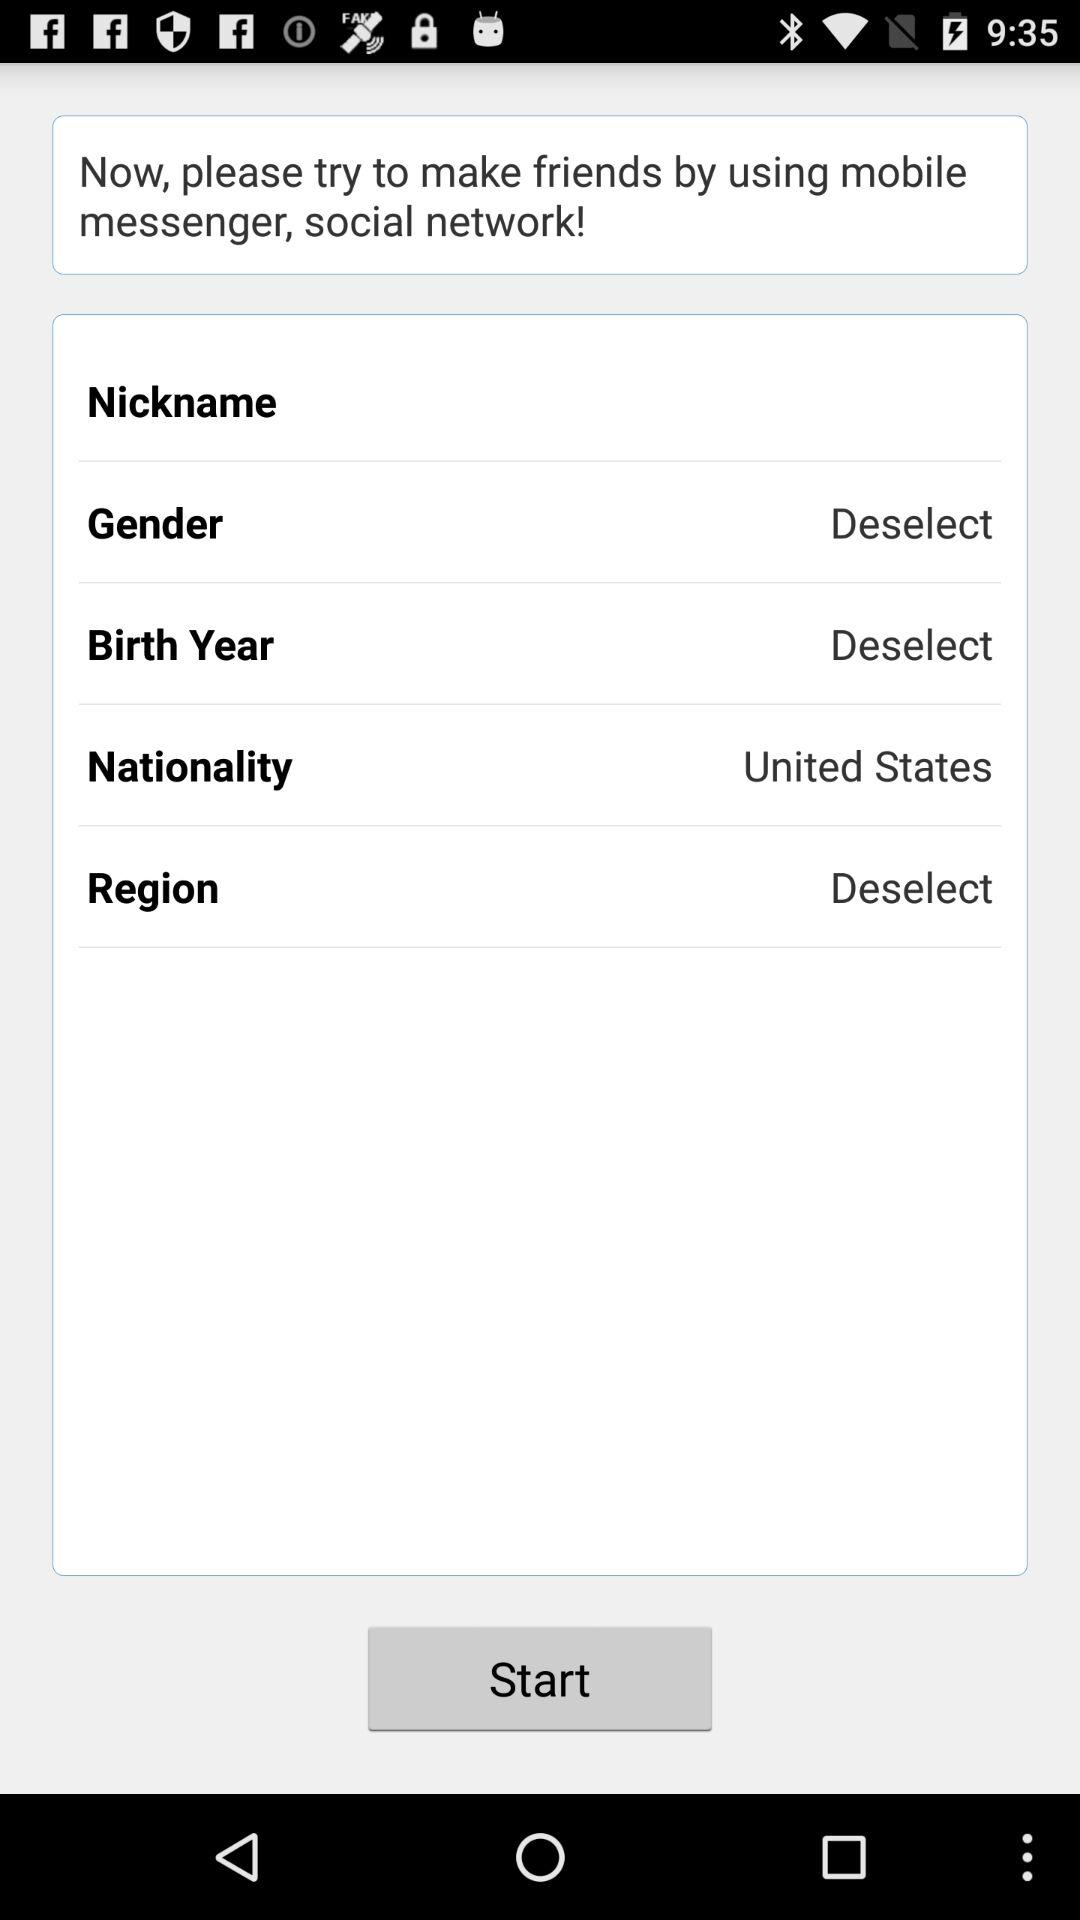What is the nationality? The nationality is the United States. 